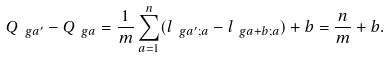Convert formula to latex. <formula><loc_0><loc_0><loc_500><loc_500>Q _ { \ g a ^ { \prime } } - Q _ { \ g a } = \frac { 1 } { m } \sum _ { a = 1 } ^ { n } ( l _ { \ g a ^ { \prime } ; a } - l _ { \ g a + b ; a } ) + b = \frac { n } { m } + b .</formula> 